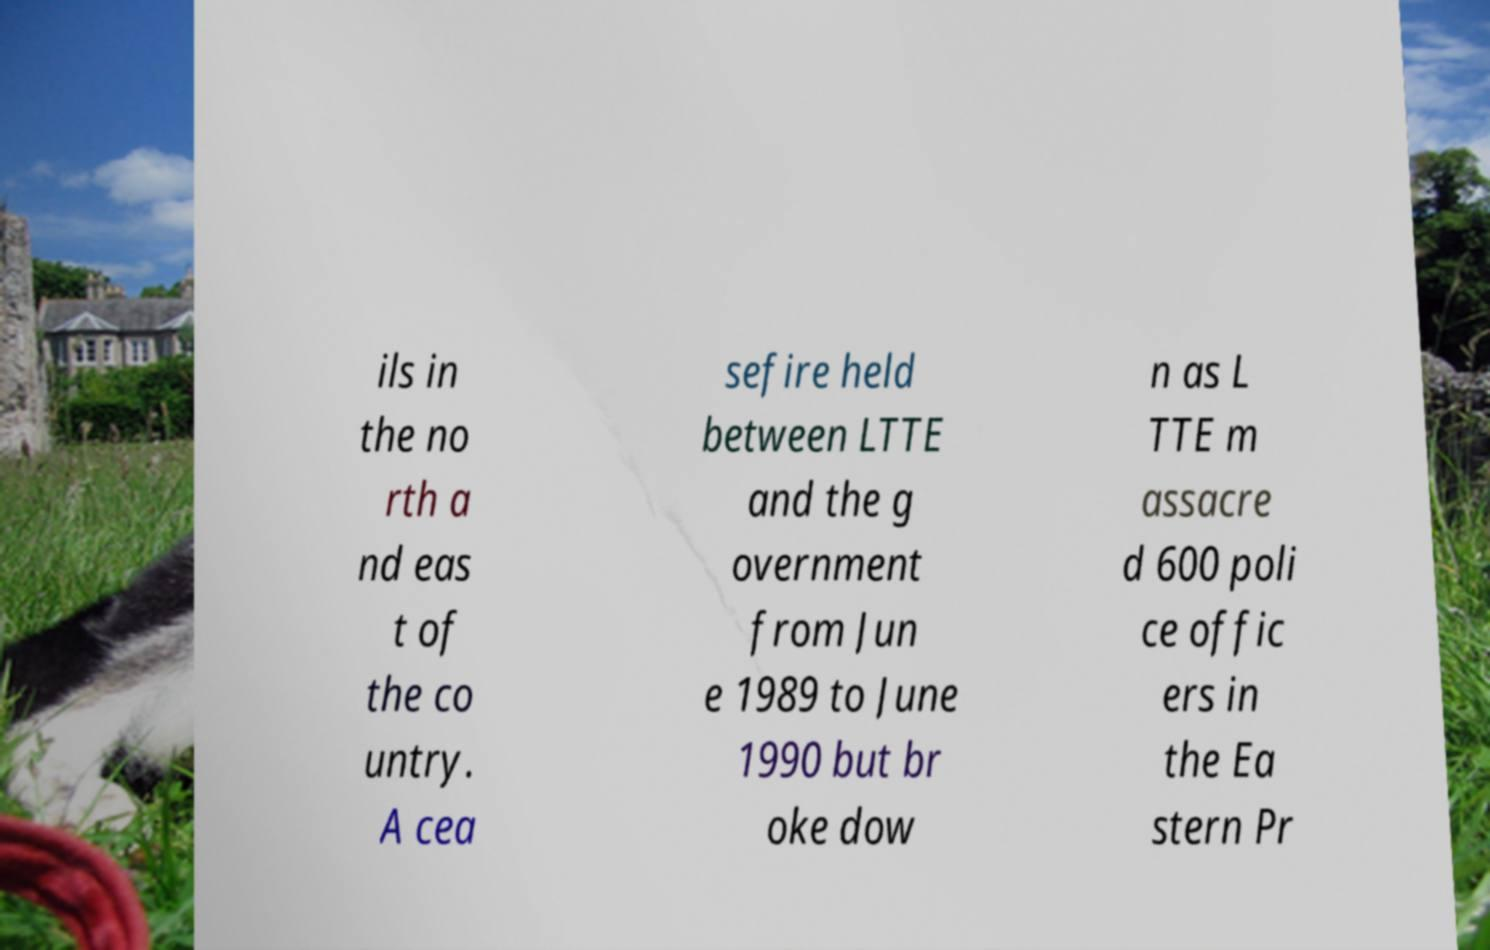Can you accurately transcribe the text from the provided image for me? ils in the no rth a nd eas t of the co untry. A cea sefire held between LTTE and the g overnment from Jun e 1989 to June 1990 but br oke dow n as L TTE m assacre d 600 poli ce offic ers in the Ea stern Pr 